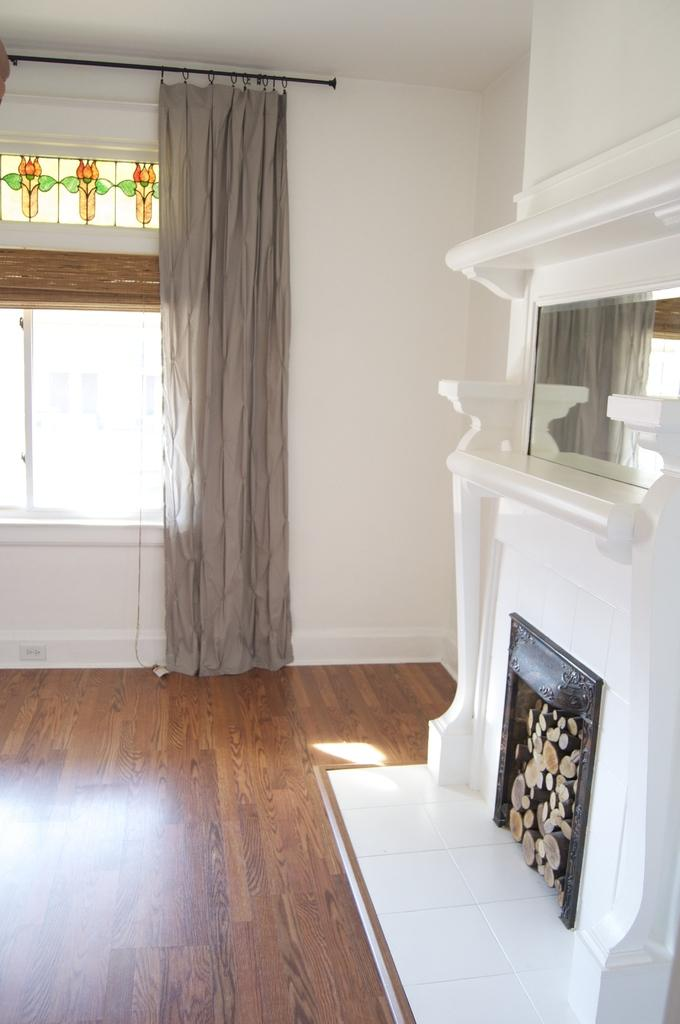What type of flooring is visible in the image? There is a wooden floor in the image. What is a notable feature in the room? There is a fireplace in the image. What can be seen on the wall? There is a mirror on the wall in the image. How are the windows treated in the image? There are curtains on the glass windows in the image. What type of crown can be seen on the fireplace mantle in the image? There is no crown present on the fireplace mantle in the image. How does the thunder sound like in the image? There is no mention of thunder in the image, as it is an indoor setting with no audible elements. 